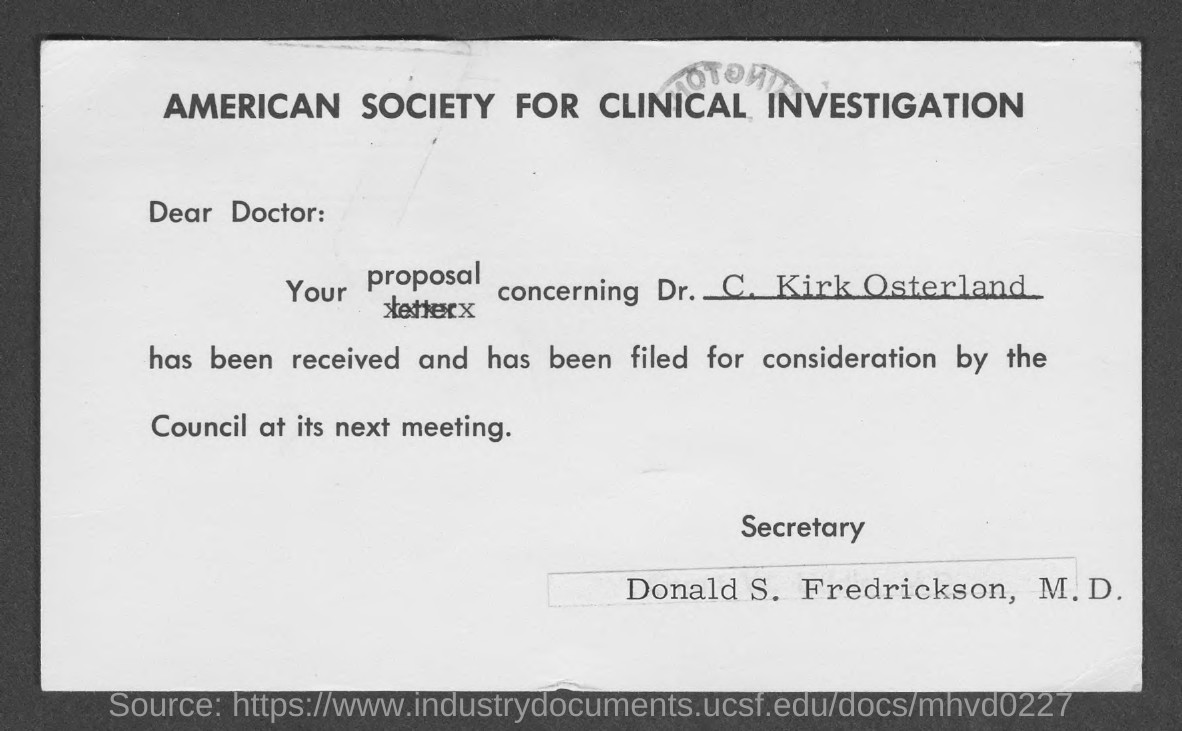The proprosal is concerning whom?
Give a very brief answer. Dr. C. Kirk Osterland. Who is the secretary?
Provide a short and direct response. Donald S. Fredrickson, M.D. 